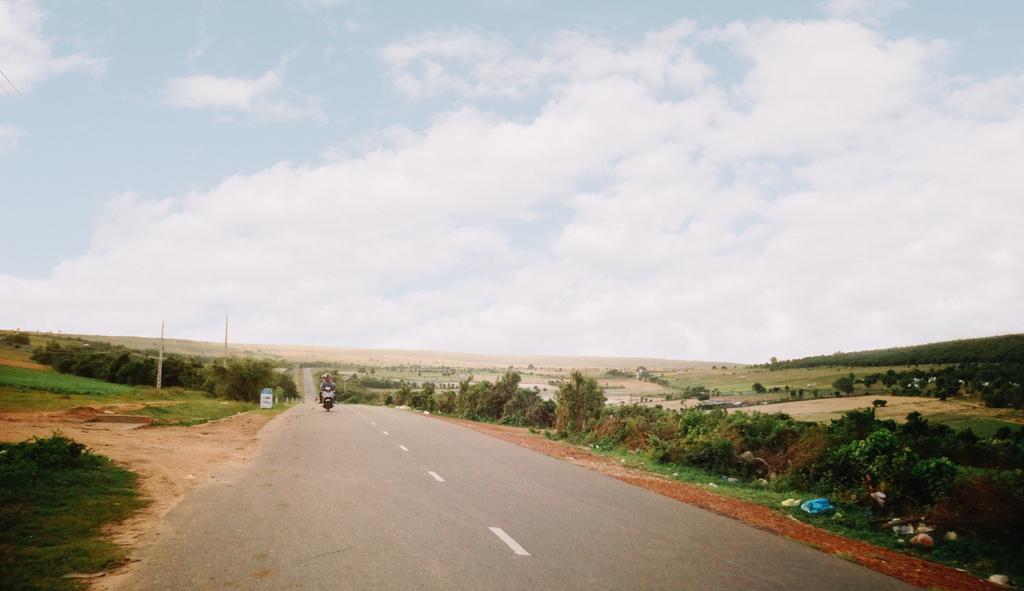How would you summarize this image in a sentence or two? This image is taken outdoors. At the top of the image there is a sky with clouds. At the bottom of the image there is a road and a ground with grass on it. In the middle of the image a man is riding on the bike. On the left and right sides of the image there are many trees and plants on the ground. 